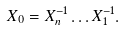Convert formula to latex. <formula><loc_0><loc_0><loc_500><loc_500>X _ { 0 } = X _ { n } ^ { - 1 } \dots X _ { 1 } ^ { - 1 } .</formula> 